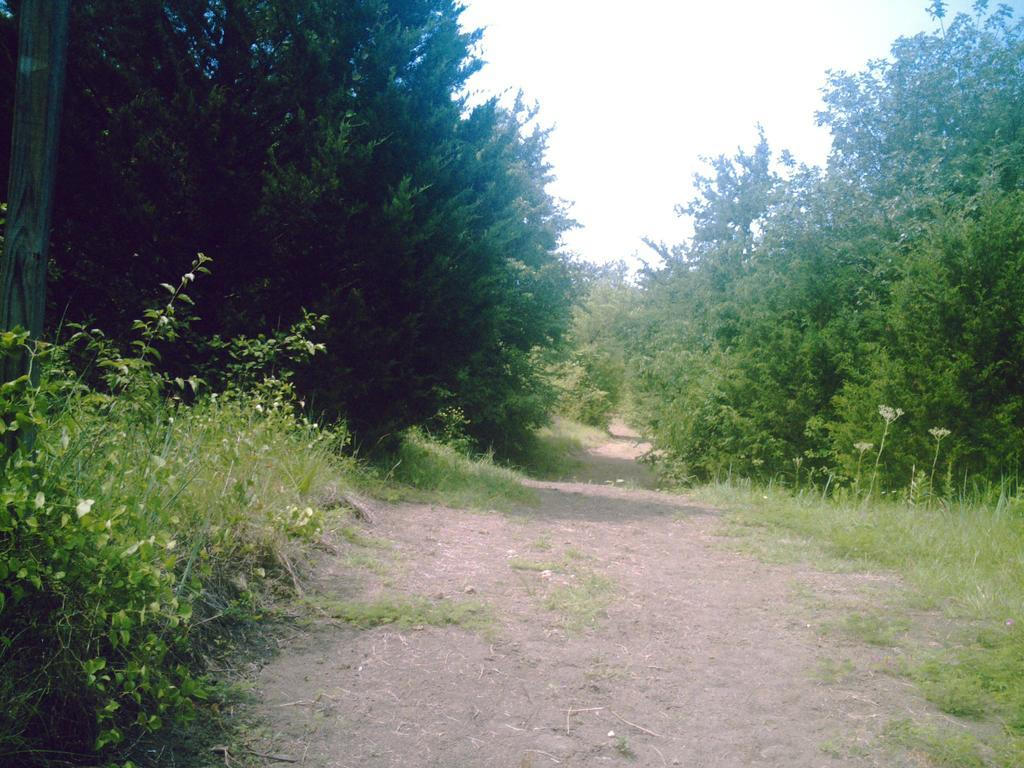What is visible at the bottom of the image? The ground is visible in the image. What types of vegetation can be seen in the image? There are many plants and trees in the image. What is visible in the background of the image? The sky is visible in the background of the image. What color is the sky in the image? The sky appears to be white in the image. Can you see any blood on the stage in the image? There is no stage or blood present in the image. How many people are walking in the image? There are no people visible in the image, so it is impossible to determine how many might be walking. 